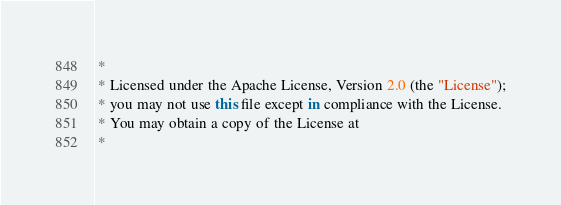<code> <loc_0><loc_0><loc_500><loc_500><_Kotlin_> *
 * Licensed under the Apache License, Version 2.0 (the "License");
 * you may not use this file except in compliance with the License.
 * You may obtain a copy of the License at
 *</code> 